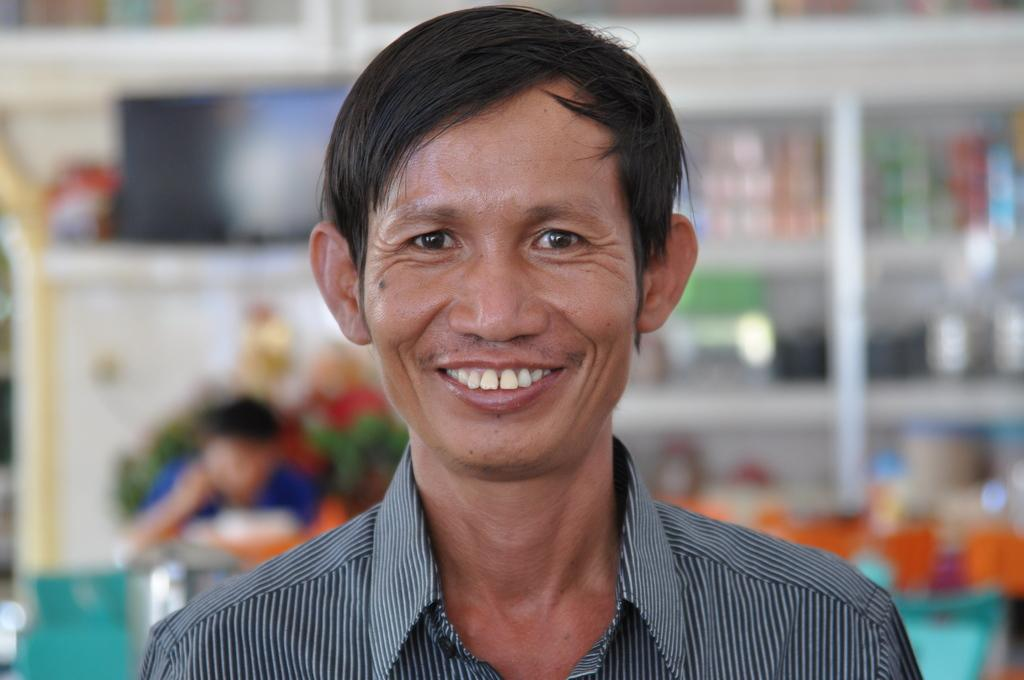What is the expression of the person in the image? The person in the image has a smile on his face. Can you describe the position of the second person in the image? There is another person behind the person in the image. What can be seen on the shelf in the image? There are items on a shelf in the image. What type of horn can be seen on the toad in the image? There is no horn or toad present in the image. How many bulbs are visible on the person's head in the image? There are no bulbs visible on the person's head in the image. 